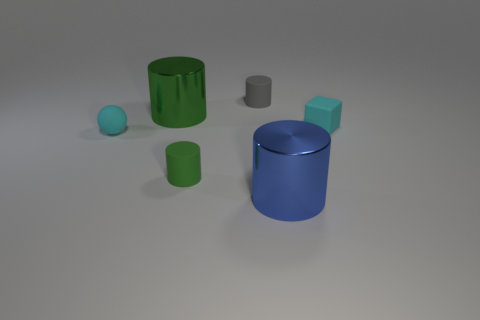Subtract all big blue cylinders. How many cylinders are left? 3 Subtract all green cubes. How many green cylinders are left? 2 Subtract all gray cylinders. How many cylinders are left? 3 Add 2 matte balls. How many objects exist? 8 Subtract all purple cylinders. Subtract all green cubes. How many cylinders are left? 4 Subtract all cylinders. How many objects are left? 2 Add 5 small gray cylinders. How many small gray cylinders exist? 6 Subtract 0 yellow balls. How many objects are left? 6 Subtract all green matte cylinders. Subtract all tiny rubber spheres. How many objects are left? 4 Add 6 cyan matte balls. How many cyan matte balls are left? 7 